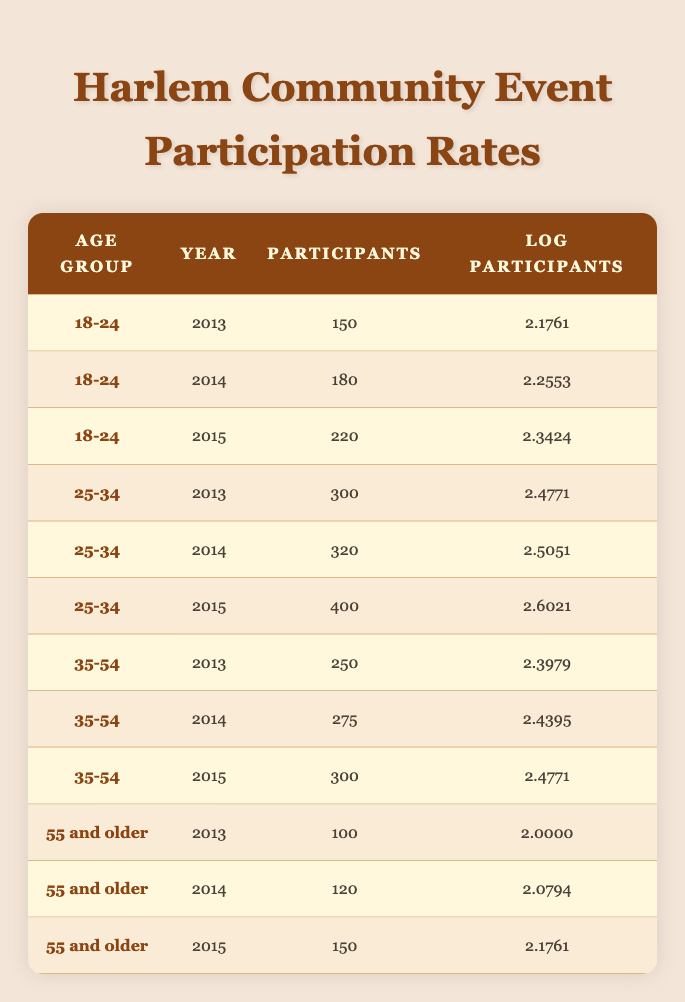What was the participation rate for the age group 25-34 in 2015? In the table, under the age group 25-34, the entry for the year 2015 shows the number of participants as 400.
Answer: 400 What is the logarithmic value of participants aged 55 and older in 2014? In the entry for the age group 55 and older for the year 2014, the logarithmic value of participants is listed as 2.0794.
Answer: 2.0794 Which age group had the highest number of participants in 2015? By examining the 2015 entries, 400 participants in the 25-34 age group is the highest compared to 220 in 18-24, 300 in 35-54, and 150 in 55 and older.
Answer: 25-34 Is the number of participants in the age group 35-54 increasing over the years listed? Comparing the years 2013 (250 participants), 2014 (275 participants), and 2015 (300 participants) for the age group 35-54 shows an increase each year, thus the statement is true.
Answer: Yes What is the total number of participants across all age groups in 2013? By adding the number of participants for 2013 for each age group: 150 (18-24) + 300 (25-34) + 250 (35-54) + 100 (55 and older) results in a total of 800 participants.
Answer: 800 What is the average number of participants for the age group 18-24 over the three years? The total for age group 18-24 is 150 (2013) + 180 (2014) + 220 (2015) = 550. There are 3 entries, so the average is 550 / 3 = 183.33.
Answer: 183.33 Did the participation in community events for the age group 55 and older ever exceed 150 participants? The data shows that in the years 2013 (100), 2014 (120), and 2015 (150) the participation for the age group 55 and older did not exceed 150 at any point.
Answer: No Which age group had the greatest increase in logarithmic participants from 2013 to 2015? The 25-34 age group increased from 2.4771 in 2013 to 2.6021 in 2015, which is an increase of 0.1250. For other age groups, the increases are less, therefore, 25-34 had the largest increase.
Answer: 25-34 What was the participation trend for the 18-24 age group from 2013 to 2015? The data shows 150 participants in 2013, increasing to 180 in 2014, and then to 220 in 2015, indicating a consistent upward trend in participation over those years.
Answer: Increasing 